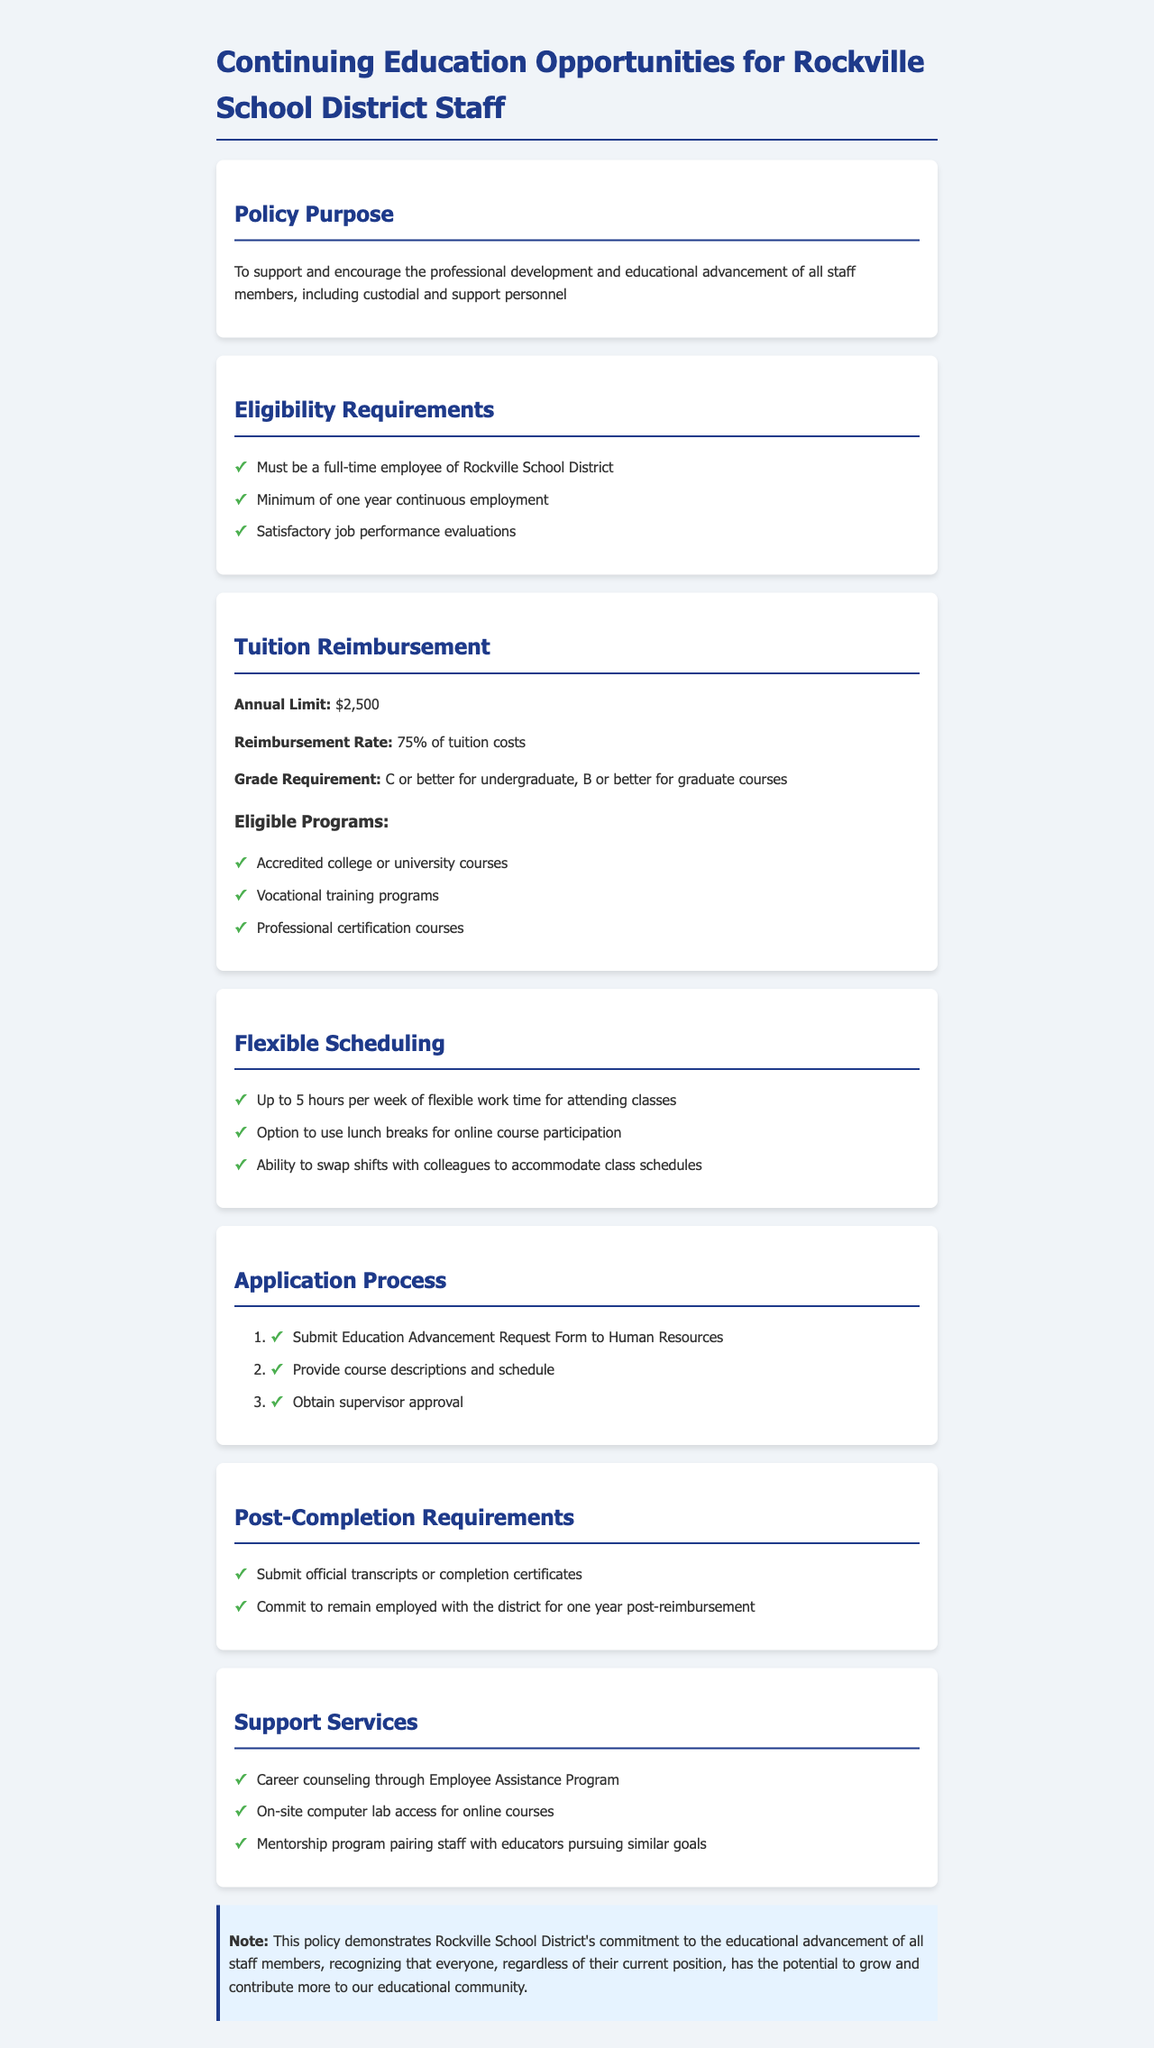What is the annual limit for tuition reimbursement? The document states that the annual limit for tuition reimbursement is $2,500.
Answer: $2,500 What percentage of tuition costs is covered by the reimbursement? The reimbursement rate mentioned in the document is 75% of tuition costs.
Answer: 75% How long must an employee have worked to be eligible? According to the eligibility requirements, an employee must have a minimum of one year continuous employment.
Answer: One year What grade is required for graduate courses to qualify for reimbursement? The document specifies that a grade of B or better is required for graduate courses to qualify for reimbursement.
Answer: B How many hours of flexible work time are available per week? The document states that employees can have up to 5 hours per week of flexible work time for attending classes.
Answer: 5 hours What must be submitted after course completion? Employees are required to submit official transcripts or completion certificates after course completion.
Answer: Official transcripts or completion certificates What document must be submitted to begin the application process? To initiate the application process, employees must submit the Education Advancement Request Form to Human Resources.
Answer: Education Advancement Request Form What support service is mentioned in relation to career counseling? The document mentions career counseling through the Employee Assistance Program as a support service.
Answer: Employee Assistance Program 